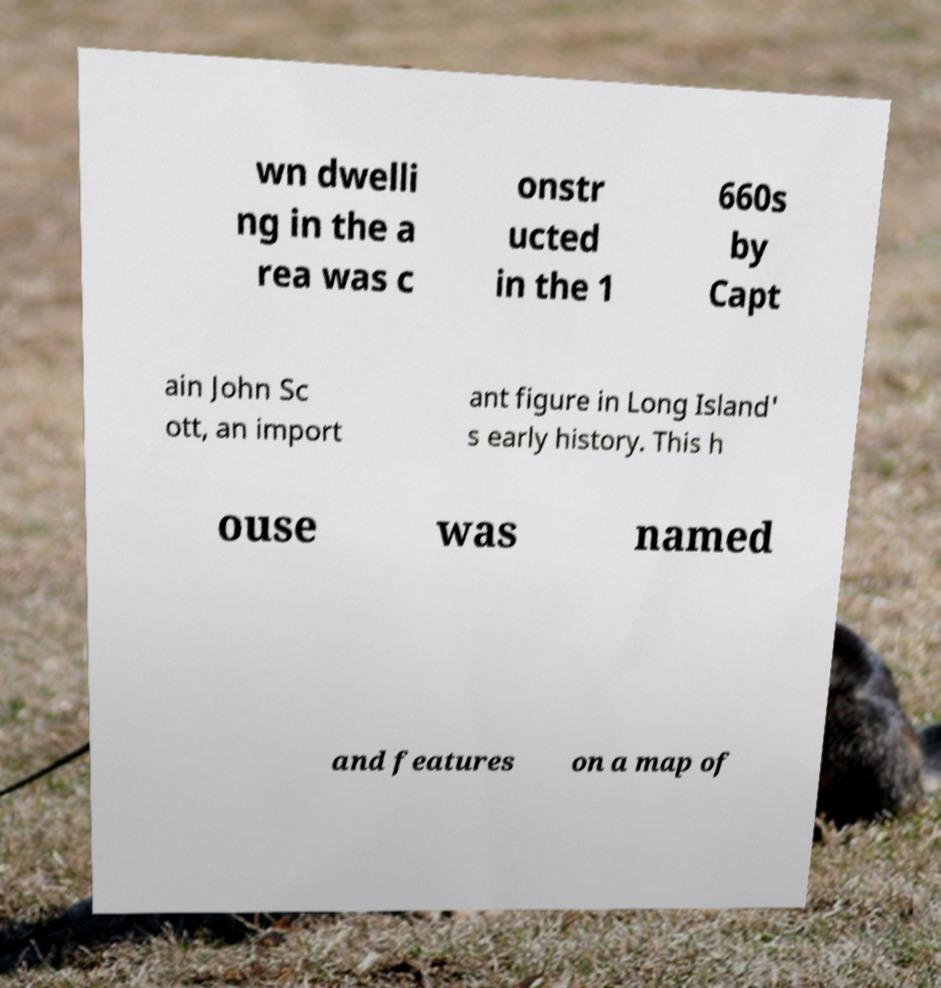Can you read and provide the text displayed in the image?This photo seems to have some interesting text. Can you extract and type it out for me? wn dwelli ng in the a rea was c onstr ucted in the 1 660s by Capt ain John Sc ott, an import ant figure in Long Island' s early history. This h ouse was named and features on a map of 